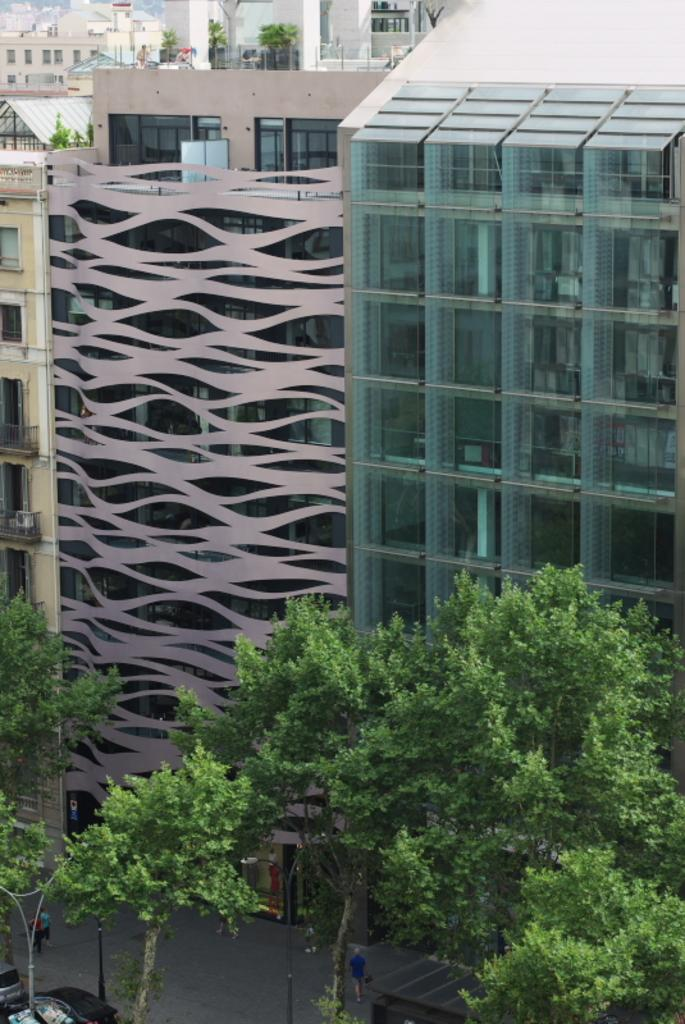What type of structures can be seen in the image? There are buildings in the image. What objects made of glass can be seen in the image? There are glass objects in the image. What architectural feature is present in the image? Railings are present in the image. What type of surfaces are visible in the image? Walls are visible in the image. What type of living organisms can be seen in the image? Plants are in the image. Where are the people located in the image? People are at the bottom of the image. What type of pathway is visible at the bottom of the image? There is a road at the bottom of the image. What type of transportation is present at the bottom of the image? Vehicles are present at the bottom of the image. What type of vertical structures are visible at the bottom of the image? Poles are visible at the bottom of the image. What type of signage is present at the bottom of the image? There is a poster at the bottom of the image. What type of tall vegetation is visible at the bottom of the image? Trees are visible at the bottom of the image. How many eggs are visible in the image? There are no eggs present in the image. Are there any icicles hanging from the buildings in the image? There are no icicles visible in the image. Can you see a snake slithering through the plants in the image? There is no snake present in the image. 